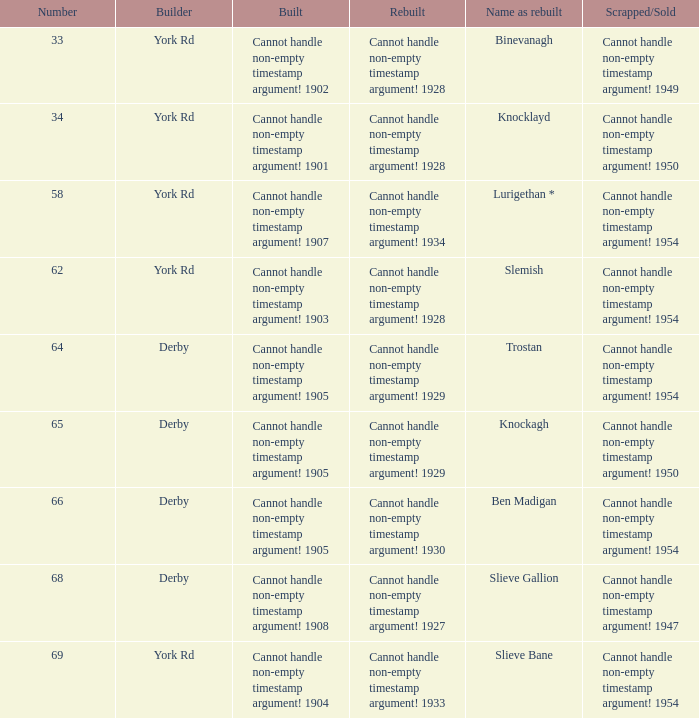Which Scrapped/Sold has a Name as rebuilt of trostan? Cannot handle non-empty timestamp argument! 1954. 